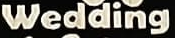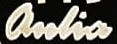What text appears in these images from left to right, separated by a semicolon? Wedding; anlia 